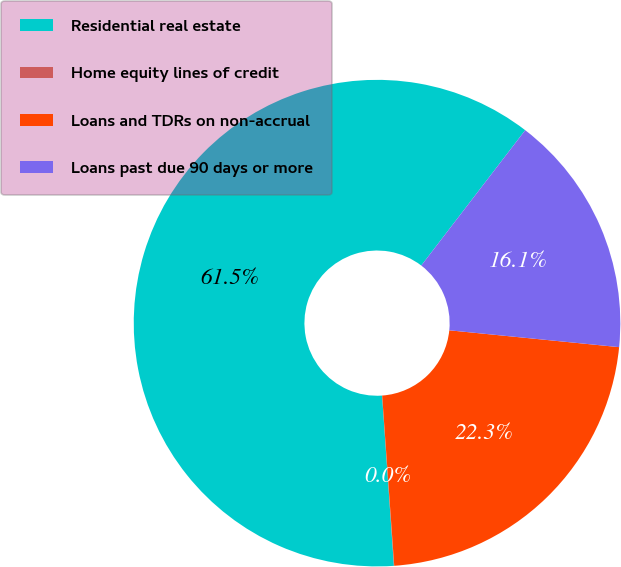<chart> <loc_0><loc_0><loc_500><loc_500><pie_chart><fcel>Residential real estate<fcel>Home equity lines of credit<fcel>Loans and TDRs on non-accrual<fcel>Loans past due 90 days or more<nl><fcel>61.53%<fcel>0.02%<fcel>22.3%<fcel>16.15%<nl></chart> 